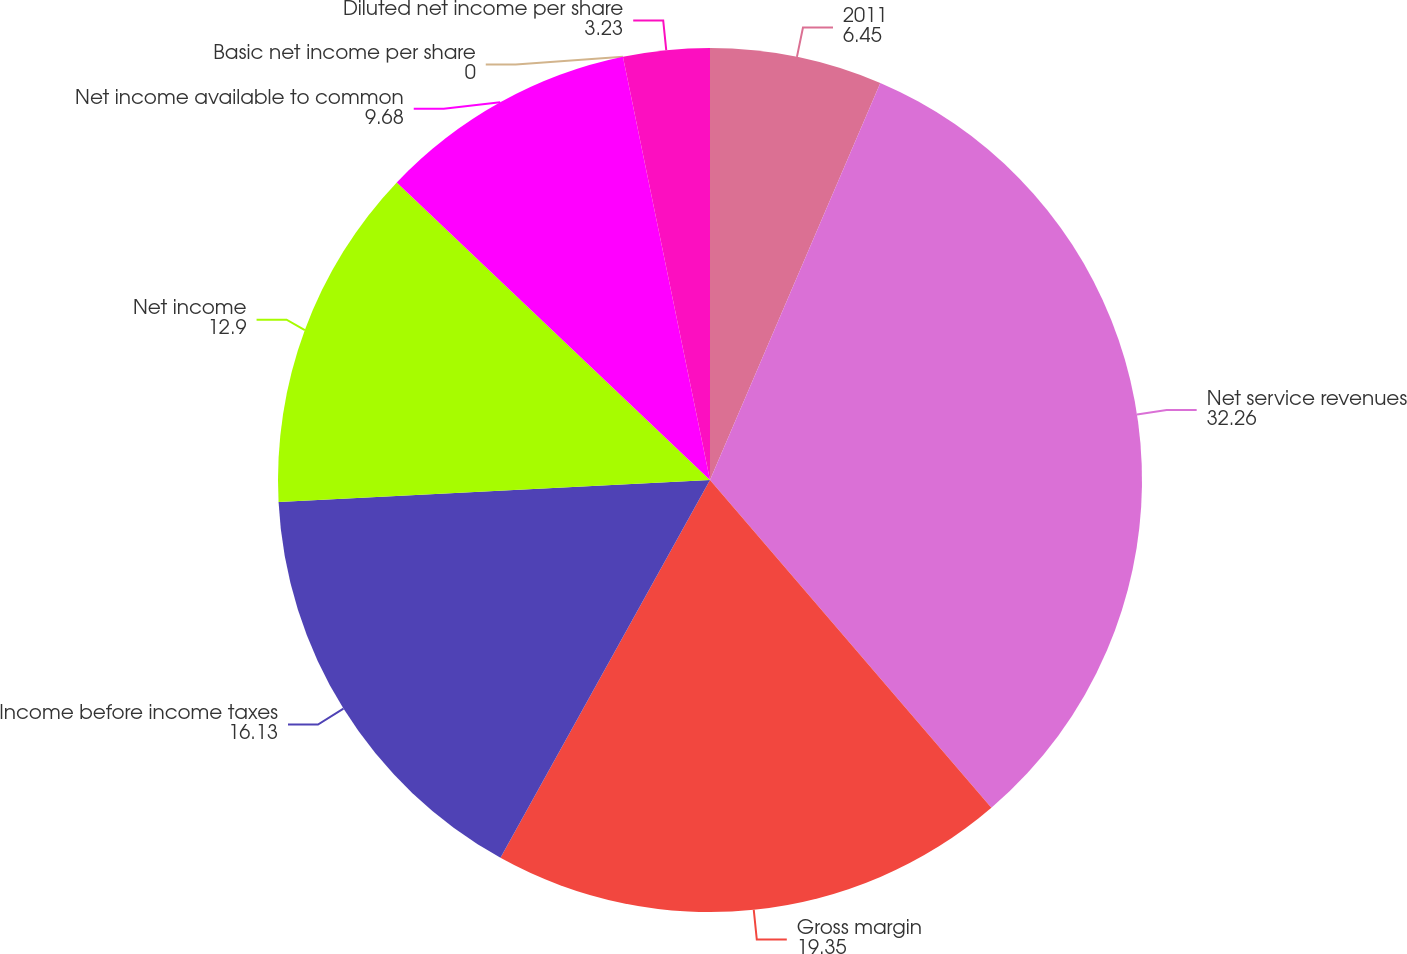Convert chart. <chart><loc_0><loc_0><loc_500><loc_500><pie_chart><fcel>2011<fcel>Net service revenues<fcel>Gross margin<fcel>Income before income taxes<fcel>Net income<fcel>Net income available to common<fcel>Basic net income per share<fcel>Diluted net income per share<nl><fcel>6.45%<fcel>32.26%<fcel>19.35%<fcel>16.13%<fcel>12.9%<fcel>9.68%<fcel>0.0%<fcel>3.23%<nl></chart> 